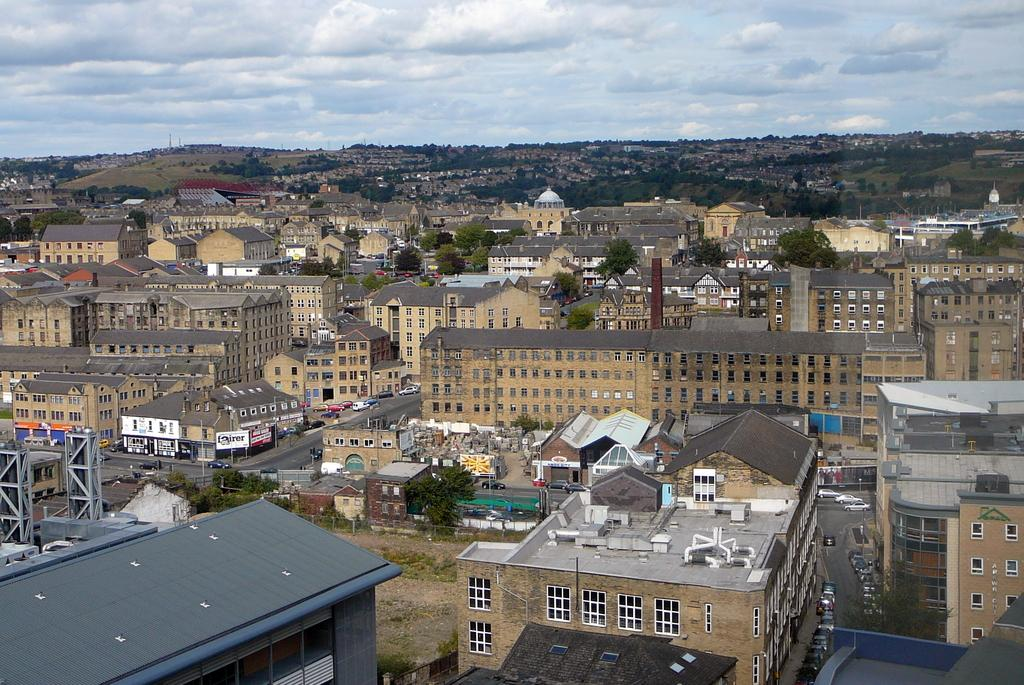What type of structures can be seen in the image? There are many buildings in the image. What architectural features are visible in the image? Walls, windows, and roofs are visible in the image. What type of transportation is present in the image? Vehicles are present in the image. What natural elements can be seen in the image? Trees are visible in the image. What man-made objects are present in the image? Poles and banners are present in the image. What is the condition of the sky in the image? The sky is cloudy at the top of the image. What type of reaction does the lawyer have when the shade is too dark in the image? There is no lawyer or shade present in the image, so it is not possible to answer that question. 